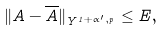<formula> <loc_0><loc_0><loc_500><loc_500>\| A - \overline { A } \| _ { Y ^ { 1 + \alpha ^ { \prime } , p } } \leq E ,</formula> 